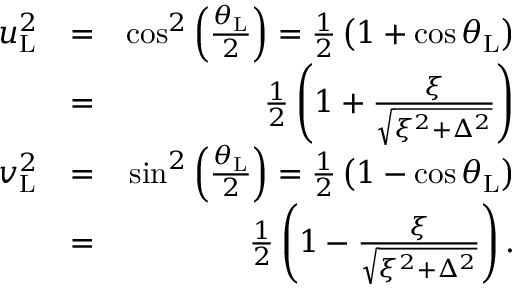<formula> <loc_0><loc_0><loc_500><loc_500>\begin{array} { r l r } { u _ { L } ^ { 2 } } & { = } & { \cos ^ { 2 } \left ( \frac { \theta _ { L } } { 2 } \right ) = \frac { 1 } { 2 } \left ( 1 + \cos \theta _ { L } \right ) } \\ & { = } & { \frac { 1 } { 2 } \left ( 1 + \frac { \xi } { \sqrt { \xi ^ { 2 } + \Delta ^ { 2 } } } \right ) } \\ { v _ { L } ^ { 2 } } & { = } & { \sin ^ { 2 } \left ( \frac { \theta _ { L } } { 2 } \right ) = \frac { 1 } { 2 } \left ( 1 - \cos \theta _ { L } \right ) } \\ & { = } & { \frac { 1 } { 2 } \left ( 1 - \frac { \xi } { \sqrt { \xi ^ { 2 } + \Delta ^ { 2 } } } \right ) . } \end{array}</formula> 